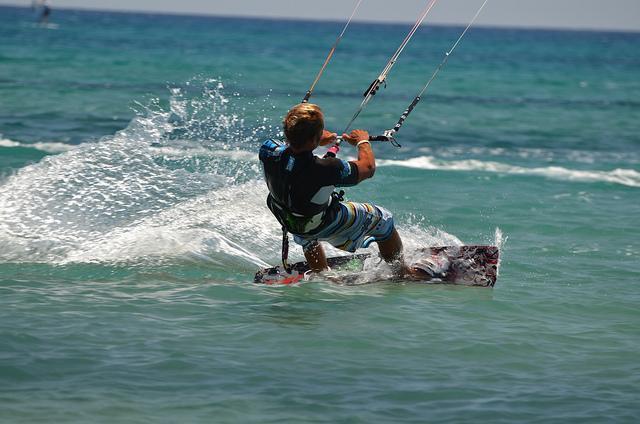How many cables come off the top of the bar?
Give a very brief answer. 3. How many people are in the picture?
Give a very brief answer. 1. 